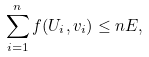Convert formula to latex. <formula><loc_0><loc_0><loc_500><loc_500>\sum _ { i = 1 } ^ { n } f ( U _ { i } , v _ { i } ) \leq n E ,</formula> 